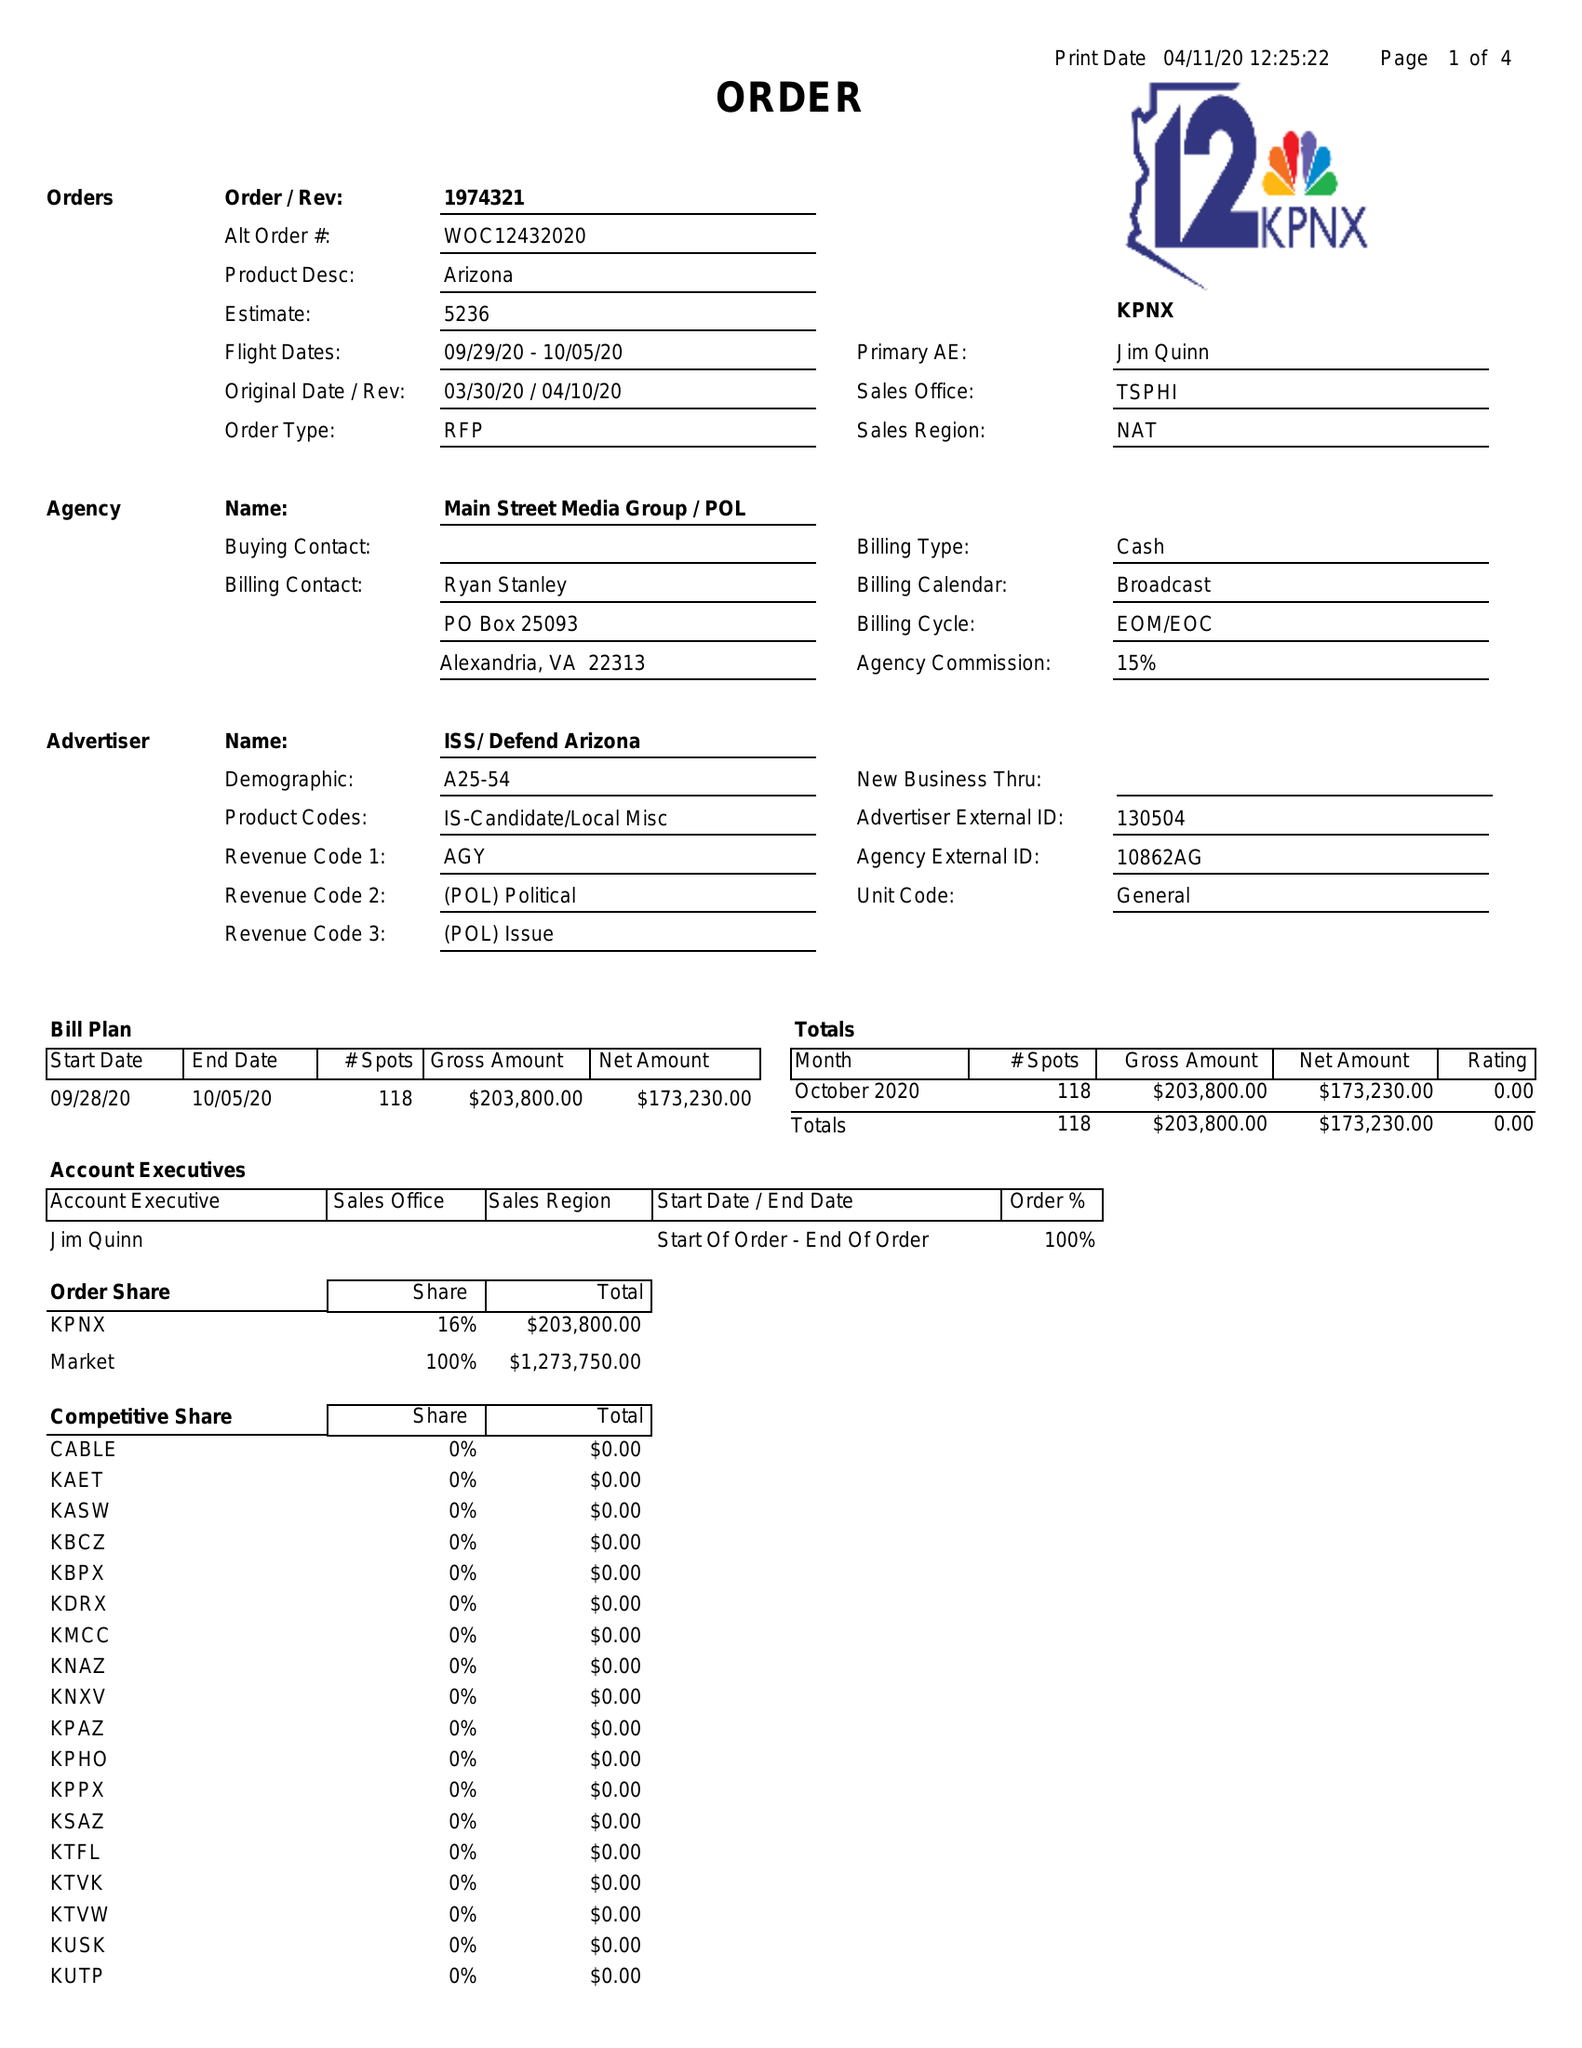What is the value for the advertiser?
Answer the question using a single word or phrase. ISS/DEFENDARIZONA 